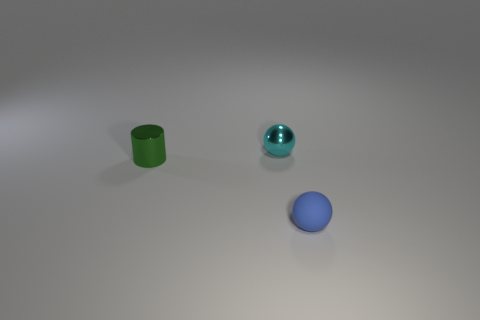How many blocks are blue objects or green metallic things?
Your response must be concise. 0. The rubber sphere has what color?
Provide a succinct answer. Blue. Is the size of the metal object that is to the left of the tiny cyan sphere the same as the blue matte thing in front of the cyan metal sphere?
Give a very brief answer. Yes. Is the number of tiny green cylinders less than the number of large brown rubber things?
Give a very brief answer. No. There is a tiny metal ball; what number of tiny green metal things are left of it?
Offer a terse response. 1. What is the green thing made of?
Your response must be concise. Metal. Is the color of the cylinder the same as the rubber object?
Give a very brief answer. No. Is the number of tiny blue rubber spheres behind the small cylinder less than the number of green cylinders?
Your answer should be compact. Yes. There is a tiny ball behind the blue sphere; what is its color?
Make the answer very short. Cyan. What shape is the matte object?
Give a very brief answer. Sphere. 